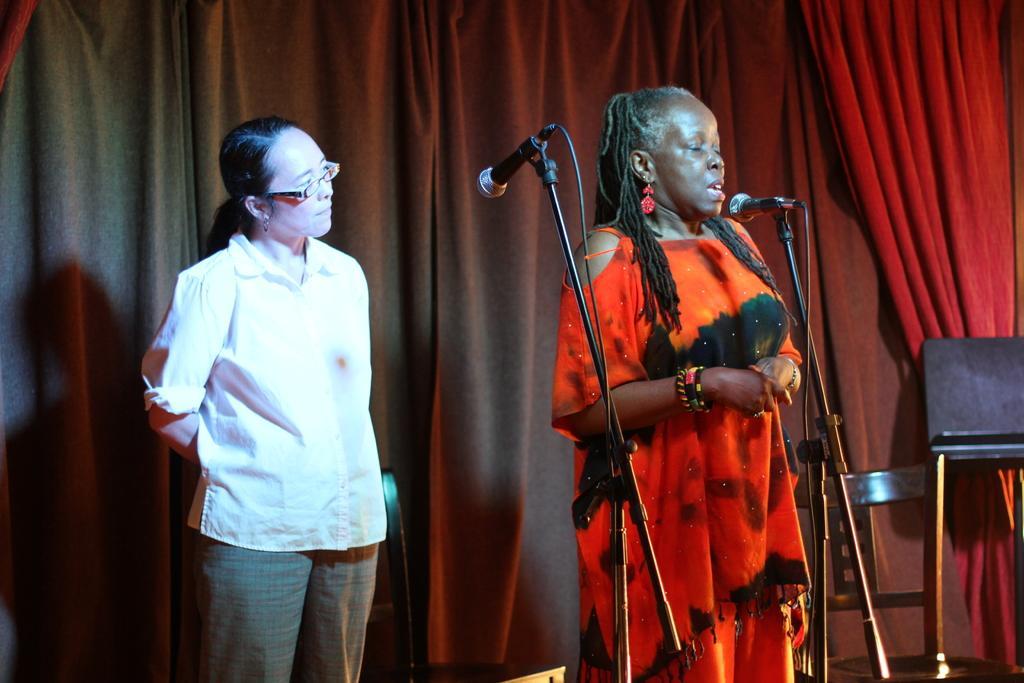Can you describe this image briefly? In the image there is a woman in orange dress talking on mic and on the left side there is another woman in white dress standing and staring, behind them there is a red curtain, on the right side there is a chair. 